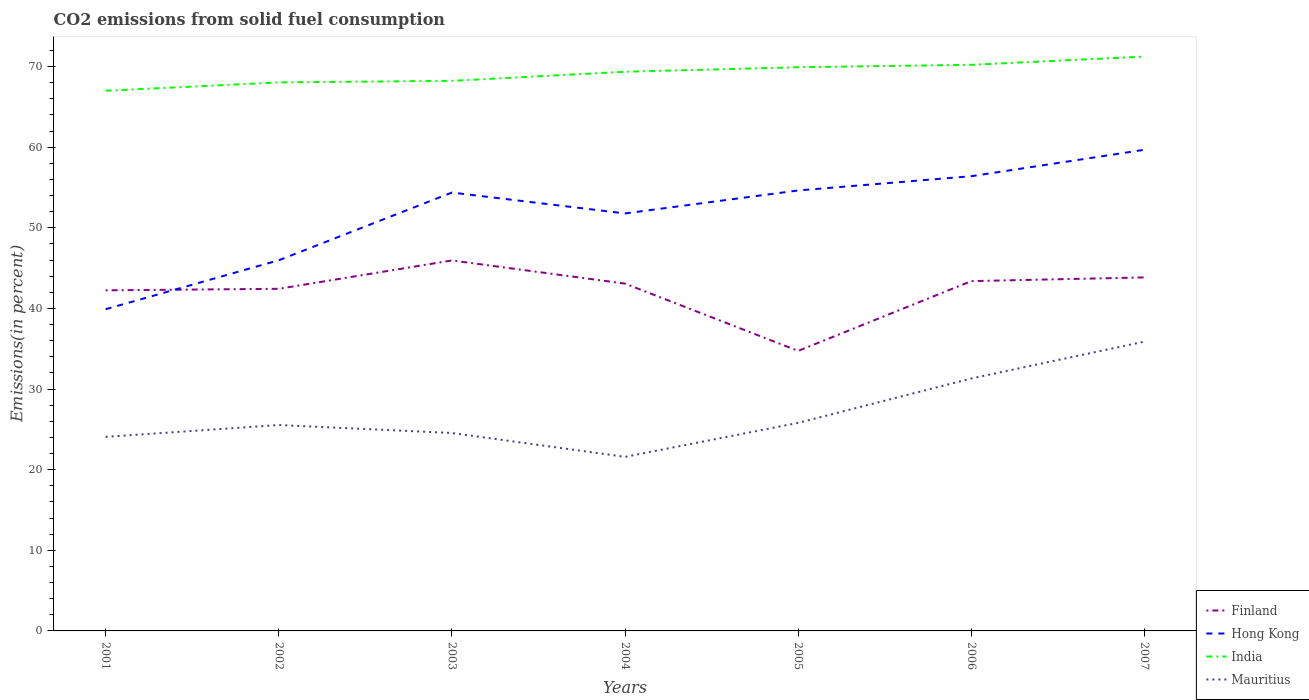Does the line corresponding to Hong Kong intersect with the line corresponding to Mauritius?
Provide a short and direct response. No. Across all years, what is the maximum total CO2 emitted in Hong Kong?
Give a very brief answer. 39.9. In which year was the total CO2 emitted in Finland maximum?
Offer a terse response. 2005. What is the total total CO2 emitted in Mauritius in the graph?
Your response must be concise. -9.72. What is the difference between the highest and the second highest total CO2 emitted in Finland?
Your answer should be very brief. 11.22. What is the difference between the highest and the lowest total CO2 emitted in Mauritius?
Your response must be concise. 2. How many years are there in the graph?
Your answer should be compact. 7. What is the difference between two consecutive major ticks on the Y-axis?
Your response must be concise. 10. Does the graph contain any zero values?
Offer a very short reply. No. How are the legend labels stacked?
Offer a terse response. Vertical. What is the title of the graph?
Your answer should be compact. CO2 emissions from solid fuel consumption. Does "Poland" appear as one of the legend labels in the graph?
Ensure brevity in your answer.  No. What is the label or title of the X-axis?
Provide a succinct answer. Years. What is the label or title of the Y-axis?
Provide a succinct answer. Emissions(in percent). What is the Emissions(in percent) of Finland in 2001?
Offer a terse response. 42.25. What is the Emissions(in percent) of Hong Kong in 2001?
Offer a terse response. 39.9. What is the Emissions(in percent) in India in 2001?
Give a very brief answer. 67. What is the Emissions(in percent) of Mauritius in 2001?
Keep it short and to the point. 24.07. What is the Emissions(in percent) in Finland in 2002?
Give a very brief answer. 42.44. What is the Emissions(in percent) of Hong Kong in 2002?
Your response must be concise. 45.98. What is the Emissions(in percent) of India in 2002?
Make the answer very short. 68.04. What is the Emissions(in percent) in Mauritius in 2002?
Provide a succinct answer. 25.54. What is the Emissions(in percent) in Finland in 2003?
Make the answer very short. 45.95. What is the Emissions(in percent) of Hong Kong in 2003?
Your answer should be compact. 54.37. What is the Emissions(in percent) in India in 2003?
Your response must be concise. 68.23. What is the Emissions(in percent) of Mauritius in 2003?
Your response must be concise. 24.55. What is the Emissions(in percent) in Finland in 2004?
Provide a succinct answer. 43.08. What is the Emissions(in percent) of Hong Kong in 2004?
Provide a succinct answer. 51.79. What is the Emissions(in percent) in India in 2004?
Offer a terse response. 69.36. What is the Emissions(in percent) of Mauritius in 2004?
Your answer should be compact. 21.59. What is the Emissions(in percent) of Finland in 2005?
Your response must be concise. 34.73. What is the Emissions(in percent) of Hong Kong in 2005?
Give a very brief answer. 54.64. What is the Emissions(in percent) in India in 2005?
Offer a terse response. 69.92. What is the Emissions(in percent) in Mauritius in 2005?
Offer a terse response. 25.81. What is the Emissions(in percent) in Finland in 2006?
Provide a short and direct response. 43.39. What is the Emissions(in percent) in Hong Kong in 2006?
Keep it short and to the point. 56.4. What is the Emissions(in percent) of India in 2006?
Keep it short and to the point. 70.22. What is the Emissions(in percent) in Mauritius in 2006?
Make the answer very short. 31.31. What is the Emissions(in percent) in Finland in 2007?
Ensure brevity in your answer.  43.85. What is the Emissions(in percent) of Hong Kong in 2007?
Your answer should be very brief. 59.68. What is the Emissions(in percent) of India in 2007?
Provide a short and direct response. 71.24. What is the Emissions(in percent) of Mauritius in 2007?
Your response must be concise. 35.88. Across all years, what is the maximum Emissions(in percent) of Finland?
Offer a terse response. 45.95. Across all years, what is the maximum Emissions(in percent) in Hong Kong?
Ensure brevity in your answer.  59.68. Across all years, what is the maximum Emissions(in percent) in India?
Give a very brief answer. 71.24. Across all years, what is the maximum Emissions(in percent) in Mauritius?
Make the answer very short. 35.88. Across all years, what is the minimum Emissions(in percent) in Finland?
Provide a short and direct response. 34.73. Across all years, what is the minimum Emissions(in percent) in Hong Kong?
Give a very brief answer. 39.9. Across all years, what is the minimum Emissions(in percent) in India?
Provide a succinct answer. 67. Across all years, what is the minimum Emissions(in percent) of Mauritius?
Your answer should be very brief. 21.59. What is the total Emissions(in percent) in Finland in the graph?
Provide a succinct answer. 295.69. What is the total Emissions(in percent) of Hong Kong in the graph?
Your answer should be compact. 362.76. What is the total Emissions(in percent) in India in the graph?
Offer a very short reply. 484. What is the total Emissions(in percent) of Mauritius in the graph?
Provide a short and direct response. 188.76. What is the difference between the Emissions(in percent) of Finland in 2001 and that in 2002?
Your answer should be very brief. -0.19. What is the difference between the Emissions(in percent) of Hong Kong in 2001 and that in 2002?
Your answer should be compact. -6.07. What is the difference between the Emissions(in percent) of India in 2001 and that in 2002?
Your answer should be very brief. -1.04. What is the difference between the Emissions(in percent) of Mauritius in 2001 and that in 2002?
Your answer should be compact. -1.47. What is the difference between the Emissions(in percent) of Finland in 2001 and that in 2003?
Keep it short and to the point. -3.7. What is the difference between the Emissions(in percent) in Hong Kong in 2001 and that in 2003?
Provide a short and direct response. -14.47. What is the difference between the Emissions(in percent) of India in 2001 and that in 2003?
Provide a succinct answer. -1.23. What is the difference between the Emissions(in percent) of Mauritius in 2001 and that in 2003?
Provide a succinct answer. -0.48. What is the difference between the Emissions(in percent) in Finland in 2001 and that in 2004?
Give a very brief answer. -0.83. What is the difference between the Emissions(in percent) of Hong Kong in 2001 and that in 2004?
Offer a very short reply. -11.88. What is the difference between the Emissions(in percent) of India in 2001 and that in 2004?
Provide a succinct answer. -2.36. What is the difference between the Emissions(in percent) in Mauritius in 2001 and that in 2004?
Offer a terse response. 2.48. What is the difference between the Emissions(in percent) of Finland in 2001 and that in 2005?
Make the answer very short. 7.51. What is the difference between the Emissions(in percent) in Hong Kong in 2001 and that in 2005?
Ensure brevity in your answer.  -14.73. What is the difference between the Emissions(in percent) of India in 2001 and that in 2005?
Offer a terse response. -2.92. What is the difference between the Emissions(in percent) in Mauritius in 2001 and that in 2005?
Provide a short and direct response. -1.73. What is the difference between the Emissions(in percent) in Finland in 2001 and that in 2006?
Provide a short and direct response. -1.14. What is the difference between the Emissions(in percent) in Hong Kong in 2001 and that in 2006?
Your answer should be very brief. -16.5. What is the difference between the Emissions(in percent) of India in 2001 and that in 2006?
Your answer should be very brief. -3.22. What is the difference between the Emissions(in percent) in Mauritius in 2001 and that in 2006?
Provide a succinct answer. -7.24. What is the difference between the Emissions(in percent) of Finland in 2001 and that in 2007?
Keep it short and to the point. -1.6. What is the difference between the Emissions(in percent) of Hong Kong in 2001 and that in 2007?
Provide a succinct answer. -19.78. What is the difference between the Emissions(in percent) of India in 2001 and that in 2007?
Make the answer very short. -4.24. What is the difference between the Emissions(in percent) in Mauritius in 2001 and that in 2007?
Keep it short and to the point. -11.81. What is the difference between the Emissions(in percent) in Finland in 2002 and that in 2003?
Offer a very short reply. -3.52. What is the difference between the Emissions(in percent) of Hong Kong in 2002 and that in 2003?
Make the answer very short. -8.4. What is the difference between the Emissions(in percent) in India in 2002 and that in 2003?
Make the answer very short. -0.19. What is the difference between the Emissions(in percent) of Mauritius in 2002 and that in 2003?
Offer a terse response. 0.99. What is the difference between the Emissions(in percent) of Finland in 2002 and that in 2004?
Your answer should be compact. -0.65. What is the difference between the Emissions(in percent) of Hong Kong in 2002 and that in 2004?
Offer a very short reply. -5.81. What is the difference between the Emissions(in percent) of India in 2002 and that in 2004?
Keep it short and to the point. -1.32. What is the difference between the Emissions(in percent) in Mauritius in 2002 and that in 2004?
Offer a very short reply. 3.95. What is the difference between the Emissions(in percent) of Finland in 2002 and that in 2005?
Provide a succinct answer. 7.7. What is the difference between the Emissions(in percent) in Hong Kong in 2002 and that in 2005?
Your answer should be compact. -8.66. What is the difference between the Emissions(in percent) of India in 2002 and that in 2005?
Your answer should be compact. -1.88. What is the difference between the Emissions(in percent) in Mauritius in 2002 and that in 2005?
Your answer should be compact. -0.27. What is the difference between the Emissions(in percent) in Finland in 2002 and that in 2006?
Make the answer very short. -0.95. What is the difference between the Emissions(in percent) of Hong Kong in 2002 and that in 2006?
Provide a succinct answer. -10.43. What is the difference between the Emissions(in percent) of India in 2002 and that in 2006?
Make the answer very short. -2.18. What is the difference between the Emissions(in percent) in Mauritius in 2002 and that in 2006?
Provide a short and direct response. -5.77. What is the difference between the Emissions(in percent) in Finland in 2002 and that in 2007?
Make the answer very short. -1.41. What is the difference between the Emissions(in percent) of Hong Kong in 2002 and that in 2007?
Offer a very short reply. -13.7. What is the difference between the Emissions(in percent) of India in 2002 and that in 2007?
Provide a succinct answer. -3.2. What is the difference between the Emissions(in percent) of Mauritius in 2002 and that in 2007?
Ensure brevity in your answer.  -10.34. What is the difference between the Emissions(in percent) of Finland in 2003 and that in 2004?
Offer a terse response. 2.87. What is the difference between the Emissions(in percent) of Hong Kong in 2003 and that in 2004?
Provide a short and direct response. 2.59. What is the difference between the Emissions(in percent) of India in 2003 and that in 2004?
Keep it short and to the point. -1.13. What is the difference between the Emissions(in percent) of Mauritius in 2003 and that in 2004?
Provide a short and direct response. 2.96. What is the difference between the Emissions(in percent) of Finland in 2003 and that in 2005?
Offer a terse response. 11.22. What is the difference between the Emissions(in percent) of Hong Kong in 2003 and that in 2005?
Your answer should be compact. -0.26. What is the difference between the Emissions(in percent) in India in 2003 and that in 2005?
Your answer should be very brief. -1.69. What is the difference between the Emissions(in percent) of Mauritius in 2003 and that in 2005?
Keep it short and to the point. -1.26. What is the difference between the Emissions(in percent) in Finland in 2003 and that in 2006?
Ensure brevity in your answer.  2.56. What is the difference between the Emissions(in percent) of Hong Kong in 2003 and that in 2006?
Keep it short and to the point. -2.03. What is the difference between the Emissions(in percent) in India in 2003 and that in 2006?
Keep it short and to the point. -1.99. What is the difference between the Emissions(in percent) in Mauritius in 2003 and that in 2006?
Your answer should be compact. -6.76. What is the difference between the Emissions(in percent) in Finland in 2003 and that in 2007?
Offer a very short reply. 2.1. What is the difference between the Emissions(in percent) of Hong Kong in 2003 and that in 2007?
Provide a short and direct response. -5.31. What is the difference between the Emissions(in percent) in India in 2003 and that in 2007?
Ensure brevity in your answer.  -3.01. What is the difference between the Emissions(in percent) in Mauritius in 2003 and that in 2007?
Provide a succinct answer. -11.33. What is the difference between the Emissions(in percent) in Finland in 2004 and that in 2005?
Provide a short and direct response. 8.35. What is the difference between the Emissions(in percent) of Hong Kong in 2004 and that in 2005?
Your response must be concise. -2.85. What is the difference between the Emissions(in percent) of India in 2004 and that in 2005?
Offer a terse response. -0.56. What is the difference between the Emissions(in percent) in Mauritius in 2004 and that in 2005?
Your response must be concise. -4.22. What is the difference between the Emissions(in percent) of Finland in 2004 and that in 2006?
Give a very brief answer. -0.31. What is the difference between the Emissions(in percent) of Hong Kong in 2004 and that in 2006?
Ensure brevity in your answer.  -4.62. What is the difference between the Emissions(in percent) in India in 2004 and that in 2006?
Your answer should be very brief. -0.86. What is the difference between the Emissions(in percent) of Mauritius in 2004 and that in 2006?
Provide a succinct answer. -9.72. What is the difference between the Emissions(in percent) of Finland in 2004 and that in 2007?
Make the answer very short. -0.77. What is the difference between the Emissions(in percent) of Hong Kong in 2004 and that in 2007?
Your answer should be very brief. -7.9. What is the difference between the Emissions(in percent) of India in 2004 and that in 2007?
Your response must be concise. -1.88. What is the difference between the Emissions(in percent) in Mauritius in 2004 and that in 2007?
Keep it short and to the point. -14.3. What is the difference between the Emissions(in percent) of Finland in 2005 and that in 2006?
Your answer should be compact. -8.66. What is the difference between the Emissions(in percent) in Hong Kong in 2005 and that in 2006?
Provide a succinct answer. -1.77. What is the difference between the Emissions(in percent) in India in 2005 and that in 2006?
Your answer should be compact. -0.3. What is the difference between the Emissions(in percent) of Mauritius in 2005 and that in 2006?
Provide a short and direct response. -5.51. What is the difference between the Emissions(in percent) in Finland in 2005 and that in 2007?
Ensure brevity in your answer.  -9.11. What is the difference between the Emissions(in percent) of Hong Kong in 2005 and that in 2007?
Make the answer very short. -5.05. What is the difference between the Emissions(in percent) in India in 2005 and that in 2007?
Offer a terse response. -1.32. What is the difference between the Emissions(in percent) in Mauritius in 2005 and that in 2007?
Offer a terse response. -10.08. What is the difference between the Emissions(in percent) in Finland in 2006 and that in 2007?
Ensure brevity in your answer.  -0.46. What is the difference between the Emissions(in percent) of Hong Kong in 2006 and that in 2007?
Give a very brief answer. -3.28. What is the difference between the Emissions(in percent) of India in 2006 and that in 2007?
Provide a short and direct response. -1.02. What is the difference between the Emissions(in percent) of Mauritius in 2006 and that in 2007?
Provide a short and direct response. -4.57. What is the difference between the Emissions(in percent) of Finland in 2001 and the Emissions(in percent) of Hong Kong in 2002?
Ensure brevity in your answer.  -3.73. What is the difference between the Emissions(in percent) of Finland in 2001 and the Emissions(in percent) of India in 2002?
Provide a short and direct response. -25.79. What is the difference between the Emissions(in percent) in Finland in 2001 and the Emissions(in percent) in Mauritius in 2002?
Give a very brief answer. 16.71. What is the difference between the Emissions(in percent) of Hong Kong in 2001 and the Emissions(in percent) of India in 2002?
Your answer should be compact. -28.14. What is the difference between the Emissions(in percent) in Hong Kong in 2001 and the Emissions(in percent) in Mauritius in 2002?
Keep it short and to the point. 14.36. What is the difference between the Emissions(in percent) in India in 2001 and the Emissions(in percent) in Mauritius in 2002?
Your answer should be compact. 41.46. What is the difference between the Emissions(in percent) of Finland in 2001 and the Emissions(in percent) of Hong Kong in 2003?
Offer a terse response. -12.13. What is the difference between the Emissions(in percent) in Finland in 2001 and the Emissions(in percent) in India in 2003?
Your response must be concise. -25.98. What is the difference between the Emissions(in percent) in Finland in 2001 and the Emissions(in percent) in Mauritius in 2003?
Make the answer very short. 17.7. What is the difference between the Emissions(in percent) in Hong Kong in 2001 and the Emissions(in percent) in India in 2003?
Offer a terse response. -28.33. What is the difference between the Emissions(in percent) of Hong Kong in 2001 and the Emissions(in percent) of Mauritius in 2003?
Offer a very short reply. 15.35. What is the difference between the Emissions(in percent) in India in 2001 and the Emissions(in percent) in Mauritius in 2003?
Your response must be concise. 42.45. What is the difference between the Emissions(in percent) of Finland in 2001 and the Emissions(in percent) of Hong Kong in 2004?
Provide a short and direct response. -9.54. What is the difference between the Emissions(in percent) of Finland in 2001 and the Emissions(in percent) of India in 2004?
Provide a short and direct response. -27.11. What is the difference between the Emissions(in percent) of Finland in 2001 and the Emissions(in percent) of Mauritius in 2004?
Provide a short and direct response. 20.66. What is the difference between the Emissions(in percent) in Hong Kong in 2001 and the Emissions(in percent) in India in 2004?
Your response must be concise. -29.45. What is the difference between the Emissions(in percent) of Hong Kong in 2001 and the Emissions(in percent) of Mauritius in 2004?
Give a very brief answer. 18.31. What is the difference between the Emissions(in percent) of India in 2001 and the Emissions(in percent) of Mauritius in 2004?
Make the answer very short. 45.41. What is the difference between the Emissions(in percent) in Finland in 2001 and the Emissions(in percent) in Hong Kong in 2005?
Your answer should be compact. -12.39. What is the difference between the Emissions(in percent) of Finland in 2001 and the Emissions(in percent) of India in 2005?
Your response must be concise. -27.67. What is the difference between the Emissions(in percent) of Finland in 2001 and the Emissions(in percent) of Mauritius in 2005?
Provide a short and direct response. 16.44. What is the difference between the Emissions(in percent) in Hong Kong in 2001 and the Emissions(in percent) in India in 2005?
Provide a succinct answer. -30.01. What is the difference between the Emissions(in percent) of Hong Kong in 2001 and the Emissions(in percent) of Mauritius in 2005?
Your answer should be very brief. 14.1. What is the difference between the Emissions(in percent) of India in 2001 and the Emissions(in percent) of Mauritius in 2005?
Provide a short and direct response. 41.19. What is the difference between the Emissions(in percent) in Finland in 2001 and the Emissions(in percent) in Hong Kong in 2006?
Ensure brevity in your answer.  -14.15. What is the difference between the Emissions(in percent) in Finland in 2001 and the Emissions(in percent) in India in 2006?
Offer a terse response. -27.97. What is the difference between the Emissions(in percent) of Finland in 2001 and the Emissions(in percent) of Mauritius in 2006?
Keep it short and to the point. 10.94. What is the difference between the Emissions(in percent) in Hong Kong in 2001 and the Emissions(in percent) in India in 2006?
Offer a terse response. -30.32. What is the difference between the Emissions(in percent) in Hong Kong in 2001 and the Emissions(in percent) in Mauritius in 2006?
Provide a short and direct response. 8.59. What is the difference between the Emissions(in percent) of India in 2001 and the Emissions(in percent) of Mauritius in 2006?
Offer a terse response. 35.69. What is the difference between the Emissions(in percent) of Finland in 2001 and the Emissions(in percent) of Hong Kong in 2007?
Your answer should be compact. -17.43. What is the difference between the Emissions(in percent) in Finland in 2001 and the Emissions(in percent) in India in 2007?
Your response must be concise. -28.99. What is the difference between the Emissions(in percent) in Finland in 2001 and the Emissions(in percent) in Mauritius in 2007?
Offer a terse response. 6.36. What is the difference between the Emissions(in percent) in Hong Kong in 2001 and the Emissions(in percent) in India in 2007?
Provide a succinct answer. -31.34. What is the difference between the Emissions(in percent) of Hong Kong in 2001 and the Emissions(in percent) of Mauritius in 2007?
Your answer should be very brief. 4.02. What is the difference between the Emissions(in percent) of India in 2001 and the Emissions(in percent) of Mauritius in 2007?
Your answer should be very brief. 31.12. What is the difference between the Emissions(in percent) of Finland in 2002 and the Emissions(in percent) of Hong Kong in 2003?
Your response must be concise. -11.94. What is the difference between the Emissions(in percent) in Finland in 2002 and the Emissions(in percent) in India in 2003?
Make the answer very short. -25.8. What is the difference between the Emissions(in percent) of Finland in 2002 and the Emissions(in percent) of Mauritius in 2003?
Make the answer very short. 17.88. What is the difference between the Emissions(in percent) of Hong Kong in 2002 and the Emissions(in percent) of India in 2003?
Offer a terse response. -22.25. What is the difference between the Emissions(in percent) in Hong Kong in 2002 and the Emissions(in percent) in Mauritius in 2003?
Offer a terse response. 21.43. What is the difference between the Emissions(in percent) of India in 2002 and the Emissions(in percent) of Mauritius in 2003?
Offer a terse response. 43.49. What is the difference between the Emissions(in percent) in Finland in 2002 and the Emissions(in percent) in Hong Kong in 2004?
Keep it short and to the point. -9.35. What is the difference between the Emissions(in percent) of Finland in 2002 and the Emissions(in percent) of India in 2004?
Provide a short and direct response. -26.92. What is the difference between the Emissions(in percent) in Finland in 2002 and the Emissions(in percent) in Mauritius in 2004?
Your answer should be very brief. 20.85. What is the difference between the Emissions(in percent) in Hong Kong in 2002 and the Emissions(in percent) in India in 2004?
Ensure brevity in your answer.  -23.38. What is the difference between the Emissions(in percent) of Hong Kong in 2002 and the Emissions(in percent) of Mauritius in 2004?
Make the answer very short. 24.39. What is the difference between the Emissions(in percent) of India in 2002 and the Emissions(in percent) of Mauritius in 2004?
Make the answer very short. 46.45. What is the difference between the Emissions(in percent) in Finland in 2002 and the Emissions(in percent) in India in 2005?
Provide a short and direct response. -27.48. What is the difference between the Emissions(in percent) in Finland in 2002 and the Emissions(in percent) in Mauritius in 2005?
Make the answer very short. 16.63. What is the difference between the Emissions(in percent) of Hong Kong in 2002 and the Emissions(in percent) of India in 2005?
Make the answer very short. -23.94. What is the difference between the Emissions(in percent) in Hong Kong in 2002 and the Emissions(in percent) in Mauritius in 2005?
Your answer should be very brief. 20.17. What is the difference between the Emissions(in percent) in India in 2002 and the Emissions(in percent) in Mauritius in 2005?
Your response must be concise. 42.23. What is the difference between the Emissions(in percent) of Finland in 2002 and the Emissions(in percent) of Hong Kong in 2006?
Your answer should be very brief. -13.97. What is the difference between the Emissions(in percent) of Finland in 2002 and the Emissions(in percent) of India in 2006?
Offer a terse response. -27.78. What is the difference between the Emissions(in percent) in Finland in 2002 and the Emissions(in percent) in Mauritius in 2006?
Your response must be concise. 11.12. What is the difference between the Emissions(in percent) of Hong Kong in 2002 and the Emissions(in percent) of India in 2006?
Your answer should be compact. -24.24. What is the difference between the Emissions(in percent) of Hong Kong in 2002 and the Emissions(in percent) of Mauritius in 2006?
Your answer should be very brief. 14.66. What is the difference between the Emissions(in percent) of India in 2002 and the Emissions(in percent) of Mauritius in 2006?
Make the answer very short. 36.73. What is the difference between the Emissions(in percent) of Finland in 2002 and the Emissions(in percent) of Hong Kong in 2007?
Your answer should be compact. -17.25. What is the difference between the Emissions(in percent) in Finland in 2002 and the Emissions(in percent) in India in 2007?
Make the answer very short. -28.8. What is the difference between the Emissions(in percent) of Finland in 2002 and the Emissions(in percent) of Mauritius in 2007?
Your answer should be very brief. 6.55. What is the difference between the Emissions(in percent) in Hong Kong in 2002 and the Emissions(in percent) in India in 2007?
Your answer should be very brief. -25.26. What is the difference between the Emissions(in percent) in Hong Kong in 2002 and the Emissions(in percent) in Mauritius in 2007?
Ensure brevity in your answer.  10.09. What is the difference between the Emissions(in percent) in India in 2002 and the Emissions(in percent) in Mauritius in 2007?
Your answer should be very brief. 32.15. What is the difference between the Emissions(in percent) in Finland in 2003 and the Emissions(in percent) in Hong Kong in 2004?
Make the answer very short. -5.83. What is the difference between the Emissions(in percent) in Finland in 2003 and the Emissions(in percent) in India in 2004?
Offer a terse response. -23.41. What is the difference between the Emissions(in percent) in Finland in 2003 and the Emissions(in percent) in Mauritius in 2004?
Offer a terse response. 24.36. What is the difference between the Emissions(in percent) in Hong Kong in 2003 and the Emissions(in percent) in India in 2004?
Your answer should be compact. -14.98. What is the difference between the Emissions(in percent) of Hong Kong in 2003 and the Emissions(in percent) of Mauritius in 2004?
Your response must be concise. 32.79. What is the difference between the Emissions(in percent) in India in 2003 and the Emissions(in percent) in Mauritius in 2004?
Your answer should be compact. 46.64. What is the difference between the Emissions(in percent) of Finland in 2003 and the Emissions(in percent) of Hong Kong in 2005?
Offer a terse response. -8.68. What is the difference between the Emissions(in percent) in Finland in 2003 and the Emissions(in percent) in India in 2005?
Provide a short and direct response. -23.97. What is the difference between the Emissions(in percent) in Finland in 2003 and the Emissions(in percent) in Mauritius in 2005?
Give a very brief answer. 20.15. What is the difference between the Emissions(in percent) of Hong Kong in 2003 and the Emissions(in percent) of India in 2005?
Provide a succinct answer. -15.54. What is the difference between the Emissions(in percent) in Hong Kong in 2003 and the Emissions(in percent) in Mauritius in 2005?
Give a very brief answer. 28.57. What is the difference between the Emissions(in percent) of India in 2003 and the Emissions(in percent) of Mauritius in 2005?
Give a very brief answer. 42.42. What is the difference between the Emissions(in percent) in Finland in 2003 and the Emissions(in percent) in Hong Kong in 2006?
Your answer should be very brief. -10.45. What is the difference between the Emissions(in percent) of Finland in 2003 and the Emissions(in percent) of India in 2006?
Your response must be concise. -24.27. What is the difference between the Emissions(in percent) in Finland in 2003 and the Emissions(in percent) in Mauritius in 2006?
Provide a succinct answer. 14.64. What is the difference between the Emissions(in percent) of Hong Kong in 2003 and the Emissions(in percent) of India in 2006?
Keep it short and to the point. -15.84. What is the difference between the Emissions(in percent) of Hong Kong in 2003 and the Emissions(in percent) of Mauritius in 2006?
Your answer should be very brief. 23.06. What is the difference between the Emissions(in percent) in India in 2003 and the Emissions(in percent) in Mauritius in 2006?
Provide a short and direct response. 36.92. What is the difference between the Emissions(in percent) of Finland in 2003 and the Emissions(in percent) of Hong Kong in 2007?
Your answer should be very brief. -13.73. What is the difference between the Emissions(in percent) in Finland in 2003 and the Emissions(in percent) in India in 2007?
Provide a succinct answer. -25.29. What is the difference between the Emissions(in percent) of Finland in 2003 and the Emissions(in percent) of Mauritius in 2007?
Your answer should be very brief. 10.07. What is the difference between the Emissions(in percent) of Hong Kong in 2003 and the Emissions(in percent) of India in 2007?
Your answer should be very brief. -16.86. What is the difference between the Emissions(in percent) in Hong Kong in 2003 and the Emissions(in percent) in Mauritius in 2007?
Your answer should be very brief. 18.49. What is the difference between the Emissions(in percent) in India in 2003 and the Emissions(in percent) in Mauritius in 2007?
Give a very brief answer. 32.35. What is the difference between the Emissions(in percent) in Finland in 2004 and the Emissions(in percent) in Hong Kong in 2005?
Your answer should be very brief. -11.55. What is the difference between the Emissions(in percent) in Finland in 2004 and the Emissions(in percent) in India in 2005?
Give a very brief answer. -26.84. What is the difference between the Emissions(in percent) in Finland in 2004 and the Emissions(in percent) in Mauritius in 2005?
Provide a succinct answer. 17.27. What is the difference between the Emissions(in percent) of Hong Kong in 2004 and the Emissions(in percent) of India in 2005?
Keep it short and to the point. -18.13. What is the difference between the Emissions(in percent) in Hong Kong in 2004 and the Emissions(in percent) in Mauritius in 2005?
Offer a terse response. 25.98. What is the difference between the Emissions(in percent) in India in 2004 and the Emissions(in percent) in Mauritius in 2005?
Your response must be concise. 43.55. What is the difference between the Emissions(in percent) in Finland in 2004 and the Emissions(in percent) in Hong Kong in 2006?
Ensure brevity in your answer.  -13.32. What is the difference between the Emissions(in percent) of Finland in 2004 and the Emissions(in percent) of India in 2006?
Provide a succinct answer. -27.14. What is the difference between the Emissions(in percent) in Finland in 2004 and the Emissions(in percent) in Mauritius in 2006?
Offer a very short reply. 11.77. What is the difference between the Emissions(in percent) of Hong Kong in 2004 and the Emissions(in percent) of India in 2006?
Ensure brevity in your answer.  -18.43. What is the difference between the Emissions(in percent) in Hong Kong in 2004 and the Emissions(in percent) in Mauritius in 2006?
Offer a terse response. 20.47. What is the difference between the Emissions(in percent) in India in 2004 and the Emissions(in percent) in Mauritius in 2006?
Offer a very short reply. 38.04. What is the difference between the Emissions(in percent) in Finland in 2004 and the Emissions(in percent) in Hong Kong in 2007?
Ensure brevity in your answer.  -16.6. What is the difference between the Emissions(in percent) of Finland in 2004 and the Emissions(in percent) of India in 2007?
Your response must be concise. -28.16. What is the difference between the Emissions(in percent) of Finland in 2004 and the Emissions(in percent) of Mauritius in 2007?
Ensure brevity in your answer.  7.2. What is the difference between the Emissions(in percent) in Hong Kong in 2004 and the Emissions(in percent) in India in 2007?
Your answer should be compact. -19.45. What is the difference between the Emissions(in percent) of Hong Kong in 2004 and the Emissions(in percent) of Mauritius in 2007?
Give a very brief answer. 15.9. What is the difference between the Emissions(in percent) of India in 2004 and the Emissions(in percent) of Mauritius in 2007?
Keep it short and to the point. 33.47. What is the difference between the Emissions(in percent) of Finland in 2005 and the Emissions(in percent) of Hong Kong in 2006?
Provide a short and direct response. -21.67. What is the difference between the Emissions(in percent) of Finland in 2005 and the Emissions(in percent) of India in 2006?
Keep it short and to the point. -35.49. What is the difference between the Emissions(in percent) of Finland in 2005 and the Emissions(in percent) of Mauritius in 2006?
Your answer should be very brief. 3.42. What is the difference between the Emissions(in percent) of Hong Kong in 2005 and the Emissions(in percent) of India in 2006?
Keep it short and to the point. -15.58. What is the difference between the Emissions(in percent) in Hong Kong in 2005 and the Emissions(in percent) in Mauritius in 2006?
Keep it short and to the point. 23.32. What is the difference between the Emissions(in percent) in India in 2005 and the Emissions(in percent) in Mauritius in 2006?
Your response must be concise. 38.6. What is the difference between the Emissions(in percent) in Finland in 2005 and the Emissions(in percent) in Hong Kong in 2007?
Provide a succinct answer. -24.95. What is the difference between the Emissions(in percent) of Finland in 2005 and the Emissions(in percent) of India in 2007?
Offer a terse response. -36.51. What is the difference between the Emissions(in percent) in Finland in 2005 and the Emissions(in percent) in Mauritius in 2007?
Offer a terse response. -1.15. What is the difference between the Emissions(in percent) of Hong Kong in 2005 and the Emissions(in percent) of India in 2007?
Offer a terse response. -16.6. What is the difference between the Emissions(in percent) of Hong Kong in 2005 and the Emissions(in percent) of Mauritius in 2007?
Provide a short and direct response. 18.75. What is the difference between the Emissions(in percent) in India in 2005 and the Emissions(in percent) in Mauritius in 2007?
Provide a short and direct response. 34.03. What is the difference between the Emissions(in percent) in Finland in 2006 and the Emissions(in percent) in Hong Kong in 2007?
Make the answer very short. -16.29. What is the difference between the Emissions(in percent) in Finland in 2006 and the Emissions(in percent) in India in 2007?
Provide a succinct answer. -27.85. What is the difference between the Emissions(in percent) in Finland in 2006 and the Emissions(in percent) in Mauritius in 2007?
Your response must be concise. 7.5. What is the difference between the Emissions(in percent) of Hong Kong in 2006 and the Emissions(in percent) of India in 2007?
Give a very brief answer. -14.84. What is the difference between the Emissions(in percent) in Hong Kong in 2006 and the Emissions(in percent) in Mauritius in 2007?
Offer a very short reply. 20.52. What is the difference between the Emissions(in percent) in India in 2006 and the Emissions(in percent) in Mauritius in 2007?
Make the answer very short. 34.33. What is the average Emissions(in percent) in Finland per year?
Offer a very short reply. 42.24. What is the average Emissions(in percent) in Hong Kong per year?
Your answer should be compact. 51.82. What is the average Emissions(in percent) in India per year?
Your response must be concise. 69.14. What is the average Emissions(in percent) of Mauritius per year?
Keep it short and to the point. 26.97. In the year 2001, what is the difference between the Emissions(in percent) in Finland and Emissions(in percent) in Hong Kong?
Offer a very short reply. 2.34. In the year 2001, what is the difference between the Emissions(in percent) of Finland and Emissions(in percent) of India?
Offer a terse response. -24.75. In the year 2001, what is the difference between the Emissions(in percent) of Finland and Emissions(in percent) of Mauritius?
Give a very brief answer. 18.18. In the year 2001, what is the difference between the Emissions(in percent) in Hong Kong and Emissions(in percent) in India?
Provide a succinct answer. -27.1. In the year 2001, what is the difference between the Emissions(in percent) in Hong Kong and Emissions(in percent) in Mauritius?
Keep it short and to the point. 15.83. In the year 2001, what is the difference between the Emissions(in percent) of India and Emissions(in percent) of Mauritius?
Offer a very short reply. 42.93. In the year 2002, what is the difference between the Emissions(in percent) in Finland and Emissions(in percent) in Hong Kong?
Your answer should be compact. -3.54. In the year 2002, what is the difference between the Emissions(in percent) of Finland and Emissions(in percent) of India?
Offer a terse response. -25.6. In the year 2002, what is the difference between the Emissions(in percent) in Finland and Emissions(in percent) in Mauritius?
Offer a very short reply. 16.89. In the year 2002, what is the difference between the Emissions(in percent) of Hong Kong and Emissions(in percent) of India?
Your answer should be compact. -22.06. In the year 2002, what is the difference between the Emissions(in percent) of Hong Kong and Emissions(in percent) of Mauritius?
Provide a succinct answer. 20.44. In the year 2002, what is the difference between the Emissions(in percent) in India and Emissions(in percent) in Mauritius?
Keep it short and to the point. 42.5. In the year 2003, what is the difference between the Emissions(in percent) of Finland and Emissions(in percent) of Hong Kong?
Provide a short and direct response. -8.42. In the year 2003, what is the difference between the Emissions(in percent) of Finland and Emissions(in percent) of India?
Your response must be concise. -22.28. In the year 2003, what is the difference between the Emissions(in percent) in Finland and Emissions(in percent) in Mauritius?
Your response must be concise. 21.4. In the year 2003, what is the difference between the Emissions(in percent) of Hong Kong and Emissions(in percent) of India?
Provide a succinct answer. -13.86. In the year 2003, what is the difference between the Emissions(in percent) of Hong Kong and Emissions(in percent) of Mauritius?
Your answer should be compact. 29.82. In the year 2003, what is the difference between the Emissions(in percent) in India and Emissions(in percent) in Mauritius?
Offer a terse response. 43.68. In the year 2004, what is the difference between the Emissions(in percent) in Finland and Emissions(in percent) in Hong Kong?
Your answer should be very brief. -8.7. In the year 2004, what is the difference between the Emissions(in percent) of Finland and Emissions(in percent) of India?
Provide a short and direct response. -26.28. In the year 2004, what is the difference between the Emissions(in percent) of Finland and Emissions(in percent) of Mauritius?
Your answer should be compact. 21.49. In the year 2004, what is the difference between the Emissions(in percent) of Hong Kong and Emissions(in percent) of India?
Make the answer very short. -17.57. In the year 2004, what is the difference between the Emissions(in percent) of Hong Kong and Emissions(in percent) of Mauritius?
Give a very brief answer. 30.2. In the year 2004, what is the difference between the Emissions(in percent) of India and Emissions(in percent) of Mauritius?
Your response must be concise. 47.77. In the year 2005, what is the difference between the Emissions(in percent) in Finland and Emissions(in percent) in Hong Kong?
Offer a terse response. -19.9. In the year 2005, what is the difference between the Emissions(in percent) in Finland and Emissions(in percent) in India?
Your response must be concise. -35.18. In the year 2005, what is the difference between the Emissions(in percent) in Finland and Emissions(in percent) in Mauritius?
Your answer should be very brief. 8.93. In the year 2005, what is the difference between the Emissions(in percent) in Hong Kong and Emissions(in percent) in India?
Provide a succinct answer. -15.28. In the year 2005, what is the difference between the Emissions(in percent) in Hong Kong and Emissions(in percent) in Mauritius?
Your answer should be very brief. 28.83. In the year 2005, what is the difference between the Emissions(in percent) of India and Emissions(in percent) of Mauritius?
Offer a very short reply. 44.11. In the year 2006, what is the difference between the Emissions(in percent) in Finland and Emissions(in percent) in Hong Kong?
Provide a succinct answer. -13.01. In the year 2006, what is the difference between the Emissions(in percent) of Finland and Emissions(in percent) of India?
Your answer should be compact. -26.83. In the year 2006, what is the difference between the Emissions(in percent) of Finland and Emissions(in percent) of Mauritius?
Make the answer very short. 12.08. In the year 2006, what is the difference between the Emissions(in percent) in Hong Kong and Emissions(in percent) in India?
Provide a short and direct response. -13.82. In the year 2006, what is the difference between the Emissions(in percent) of Hong Kong and Emissions(in percent) of Mauritius?
Your response must be concise. 25.09. In the year 2006, what is the difference between the Emissions(in percent) in India and Emissions(in percent) in Mauritius?
Provide a short and direct response. 38.91. In the year 2007, what is the difference between the Emissions(in percent) of Finland and Emissions(in percent) of Hong Kong?
Provide a short and direct response. -15.83. In the year 2007, what is the difference between the Emissions(in percent) in Finland and Emissions(in percent) in India?
Your answer should be very brief. -27.39. In the year 2007, what is the difference between the Emissions(in percent) in Finland and Emissions(in percent) in Mauritius?
Your answer should be very brief. 7.96. In the year 2007, what is the difference between the Emissions(in percent) in Hong Kong and Emissions(in percent) in India?
Give a very brief answer. -11.56. In the year 2007, what is the difference between the Emissions(in percent) in Hong Kong and Emissions(in percent) in Mauritius?
Give a very brief answer. 23.8. In the year 2007, what is the difference between the Emissions(in percent) of India and Emissions(in percent) of Mauritius?
Give a very brief answer. 35.35. What is the ratio of the Emissions(in percent) of Hong Kong in 2001 to that in 2002?
Make the answer very short. 0.87. What is the ratio of the Emissions(in percent) in India in 2001 to that in 2002?
Keep it short and to the point. 0.98. What is the ratio of the Emissions(in percent) of Mauritius in 2001 to that in 2002?
Your answer should be very brief. 0.94. What is the ratio of the Emissions(in percent) of Finland in 2001 to that in 2003?
Your response must be concise. 0.92. What is the ratio of the Emissions(in percent) of Hong Kong in 2001 to that in 2003?
Make the answer very short. 0.73. What is the ratio of the Emissions(in percent) of Mauritius in 2001 to that in 2003?
Provide a short and direct response. 0.98. What is the ratio of the Emissions(in percent) in Finland in 2001 to that in 2004?
Give a very brief answer. 0.98. What is the ratio of the Emissions(in percent) of Hong Kong in 2001 to that in 2004?
Your answer should be compact. 0.77. What is the ratio of the Emissions(in percent) of India in 2001 to that in 2004?
Give a very brief answer. 0.97. What is the ratio of the Emissions(in percent) in Mauritius in 2001 to that in 2004?
Provide a succinct answer. 1.11. What is the ratio of the Emissions(in percent) of Finland in 2001 to that in 2005?
Offer a terse response. 1.22. What is the ratio of the Emissions(in percent) in Hong Kong in 2001 to that in 2005?
Ensure brevity in your answer.  0.73. What is the ratio of the Emissions(in percent) in India in 2001 to that in 2005?
Keep it short and to the point. 0.96. What is the ratio of the Emissions(in percent) of Mauritius in 2001 to that in 2005?
Your response must be concise. 0.93. What is the ratio of the Emissions(in percent) in Finland in 2001 to that in 2006?
Provide a succinct answer. 0.97. What is the ratio of the Emissions(in percent) of Hong Kong in 2001 to that in 2006?
Your response must be concise. 0.71. What is the ratio of the Emissions(in percent) in India in 2001 to that in 2006?
Ensure brevity in your answer.  0.95. What is the ratio of the Emissions(in percent) of Mauritius in 2001 to that in 2006?
Provide a succinct answer. 0.77. What is the ratio of the Emissions(in percent) in Finland in 2001 to that in 2007?
Make the answer very short. 0.96. What is the ratio of the Emissions(in percent) of Hong Kong in 2001 to that in 2007?
Give a very brief answer. 0.67. What is the ratio of the Emissions(in percent) in India in 2001 to that in 2007?
Ensure brevity in your answer.  0.94. What is the ratio of the Emissions(in percent) of Mauritius in 2001 to that in 2007?
Your answer should be compact. 0.67. What is the ratio of the Emissions(in percent) of Finland in 2002 to that in 2003?
Ensure brevity in your answer.  0.92. What is the ratio of the Emissions(in percent) in Hong Kong in 2002 to that in 2003?
Provide a short and direct response. 0.85. What is the ratio of the Emissions(in percent) of Mauritius in 2002 to that in 2003?
Make the answer very short. 1.04. What is the ratio of the Emissions(in percent) of Hong Kong in 2002 to that in 2004?
Offer a terse response. 0.89. What is the ratio of the Emissions(in percent) of India in 2002 to that in 2004?
Provide a succinct answer. 0.98. What is the ratio of the Emissions(in percent) of Mauritius in 2002 to that in 2004?
Offer a very short reply. 1.18. What is the ratio of the Emissions(in percent) of Finland in 2002 to that in 2005?
Provide a succinct answer. 1.22. What is the ratio of the Emissions(in percent) in Hong Kong in 2002 to that in 2005?
Provide a short and direct response. 0.84. What is the ratio of the Emissions(in percent) in India in 2002 to that in 2005?
Keep it short and to the point. 0.97. What is the ratio of the Emissions(in percent) in Finland in 2002 to that in 2006?
Your answer should be very brief. 0.98. What is the ratio of the Emissions(in percent) of Hong Kong in 2002 to that in 2006?
Your response must be concise. 0.82. What is the ratio of the Emissions(in percent) of India in 2002 to that in 2006?
Make the answer very short. 0.97. What is the ratio of the Emissions(in percent) of Mauritius in 2002 to that in 2006?
Keep it short and to the point. 0.82. What is the ratio of the Emissions(in percent) in Finland in 2002 to that in 2007?
Offer a terse response. 0.97. What is the ratio of the Emissions(in percent) of Hong Kong in 2002 to that in 2007?
Your answer should be very brief. 0.77. What is the ratio of the Emissions(in percent) of India in 2002 to that in 2007?
Make the answer very short. 0.96. What is the ratio of the Emissions(in percent) of Mauritius in 2002 to that in 2007?
Your response must be concise. 0.71. What is the ratio of the Emissions(in percent) of Finland in 2003 to that in 2004?
Provide a succinct answer. 1.07. What is the ratio of the Emissions(in percent) in India in 2003 to that in 2004?
Provide a succinct answer. 0.98. What is the ratio of the Emissions(in percent) of Mauritius in 2003 to that in 2004?
Give a very brief answer. 1.14. What is the ratio of the Emissions(in percent) of Finland in 2003 to that in 2005?
Make the answer very short. 1.32. What is the ratio of the Emissions(in percent) of India in 2003 to that in 2005?
Offer a terse response. 0.98. What is the ratio of the Emissions(in percent) of Mauritius in 2003 to that in 2005?
Give a very brief answer. 0.95. What is the ratio of the Emissions(in percent) of Finland in 2003 to that in 2006?
Your answer should be very brief. 1.06. What is the ratio of the Emissions(in percent) in Hong Kong in 2003 to that in 2006?
Your answer should be compact. 0.96. What is the ratio of the Emissions(in percent) in India in 2003 to that in 2006?
Provide a short and direct response. 0.97. What is the ratio of the Emissions(in percent) in Mauritius in 2003 to that in 2006?
Provide a short and direct response. 0.78. What is the ratio of the Emissions(in percent) of Finland in 2003 to that in 2007?
Offer a terse response. 1.05. What is the ratio of the Emissions(in percent) in Hong Kong in 2003 to that in 2007?
Give a very brief answer. 0.91. What is the ratio of the Emissions(in percent) in India in 2003 to that in 2007?
Ensure brevity in your answer.  0.96. What is the ratio of the Emissions(in percent) in Mauritius in 2003 to that in 2007?
Keep it short and to the point. 0.68. What is the ratio of the Emissions(in percent) of Finland in 2004 to that in 2005?
Make the answer very short. 1.24. What is the ratio of the Emissions(in percent) in Hong Kong in 2004 to that in 2005?
Your response must be concise. 0.95. What is the ratio of the Emissions(in percent) of Mauritius in 2004 to that in 2005?
Your answer should be very brief. 0.84. What is the ratio of the Emissions(in percent) of Hong Kong in 2004 to that in 2006?
Your answer should be compact. 0.92. What is the ratio of the Emissions(in percent) of Mauritius in 2004 to that in 2006?
Provide a short and direct response. 0.69. What is the ratio of the Emissions(in percent) in Finland in 2004 to that in 2007?
Ensure brevity in your answer.  0.98. What is the ratio of the Emissions(in percent) in Hong Kong in 2004 to that in 2007?
Your answer should be compact. 0.87. What is the ratio of the Emissions(in percent) of India in 2004 to that in 2007?
Your response must be concise. 0.97. What is the ratio of the Emissions(in percent) in Mauritius in 2004 to that in 2007?
Offer a terse response. 0.6. What is the ratio of the Emissions(in percent) of Finland in 2005 to that in 2006?
Your answer should be very brief. 0.8. What is the ratio of the Emissions(in percent) of Hong Kong in 2005 to that in 2006?
Offer a very short reply. 0.97. What is the ratio of the Emissions(in percent) of Mauritius in 2005 to that in 2006?
Your answer should be very brief. 0.82. What is the ratio of the Emissions(in percent) of Finland in 2005 to that in 2007?
Make the answer very short. 0.79. What is the ratio of the Emissions(in percent) of Hong Kong in 2005 to that in 2007?
Make the answer very short. 0.92. What is the ratio of the Emissions(in percent) in India in 2005 to that in 2007?
Provide a short and direct response. 0.98. What is the ratio of the Emissions(in percent) of Mauritius in 2005 to that in 2007?
Offer a terse response. 0.72. What is the ratio of the Emissions(in percent) of Hong Kong in 2006 to that in 2007?
Your answer should be very brief. 0.94. What is the ratio of the Emissions(in percent) in India in 2006 to that in 2007?
Keep it short and to the point. 0.99. What is the ratio of the Emissions(in percent) in Mauritius in 2006 to that in 2007?
Make the answer very short. 0.87. What is the difference between the highest and the second highest Emissions(in percent) of Finland?
Offer a terse response. 2.1. What is the difference between the highest and the second highest Emissions(in percent) in Hong Kong?
Offer a very short reply. 3.28. What is the difference between the highest and the second highest Emissions(in percent) in India?
Make the answer very short. 1.02. What is the difference between the highest and the second highest Emissions(in percent) of Mauritius?
Provide a succinct answer. 4.57. What is the difference between the highest and the lowest Emissions(in percent) of Finland?
Offer a terse response. 11.22. What is the difference between the highest and the lowest Emissions(in percent) in Hong Kong?
Provide a succinct answer. 19.78. What is the difference between the highest and the lowest Emissions(in percent) in India?
Keep it short and to the point. 4.24. What is the difference between the highest and the lowest Emissions(in percent) of Mauritius?
Offer a terse response. 14.3. 